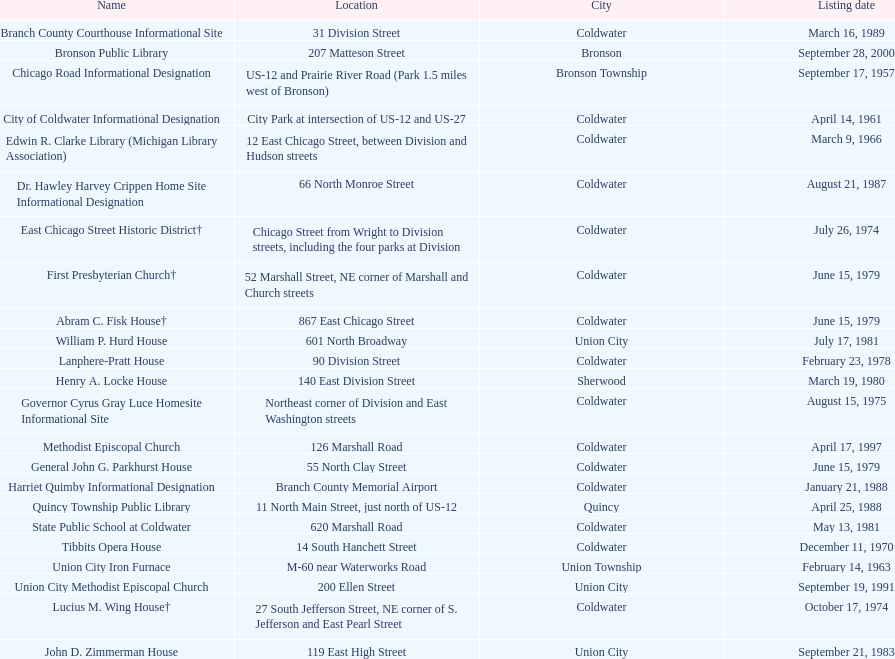Write the full table. {'header': ['Name', 'Location', 'City', 'Listing date'], 'rows': [['Branch County Courthouse Informational Site', '31 Division Street', 'Coldwater', 'March 16, 1989'], ['Bronson Public Library', '207 Matteson Street', 'Bronson', 'September 28, 2000'], ['Chicago Road Informational Designation', 'US-12 and Prairie River Road (Park 1.5 miles west of Bronson)', 'Bronson Township', 'September 17, 1957'], ['City of Coldwater Informational Designation', 'City Park at intersection of US-12 and US-27', 'Coldwater', 'April 14, 1961'], ['Edwin R. Clarke Library (Michigan Library Association)', '12 East Chicago Street, between Division and Hudson streets', 'Coldwater', 'March 9, 1966'], ['Dr. Hawley Harvey Crippen Home Site Informational Designation', '66 North Monroe Street', 'Coldwater', 'August 21, 1987'], ['East Chicago Street Historic District†', 'Chicago Street from Wright to Division streets, including the four parks at Division', 'Coldwater', 'July 26, 1974'], ['First Presbyterian Church†', '52 Marshall Street, NE corner of Marshall and Church streets', 'Coldwater', 'June 15, 1979'], ['Abram C. Fisk House†', '867 East Chicago Street', 'Coldwater', 'June 15, 1979'], ['William P. Hurd House', '601 North Broadway', 'Union City', 'July 17, 1981'], ['Lanphere-Pratt House', '90 Division Street', 'Coldwater', 'February 23, 1978'], ['Henry A. Locke House', '140 East Division Street', 'Sherwood', 'March 19, 1980'], ['Governor Cyrus Gray Luce Homesite Informational Site', 'Northeast corner of Division and East Washington streets', 'Coldwater', 'August 15, 1975'], ['Methodist Episcopal Church', '126 Marshall Road', 'Coldwater', 'April 17, 1997'], ['General John G. Parkhurst House', '55 North Clay Street', 'Coldwater', 'June 15, 1979'], ['Harriet Quimby Informational Designation', 'Branch County Memorial Airport', 'Coldwater', 'January 21, 1988'], ['Quincy Township Public Library', '11 North Main Street, just north of US-12', 'Quincy', 'April 25, 1988'], ['State Public School at Coldwater', '620 Marshall Road', 'Coldwater', 'May 13, 1981'], ['Tibbits Opera House', '14 South Hanchett Street', 'Coldwater', 'December 11, 1970'], ['Union City Iron Furnace', 'M-60 near Waterworks Road', 'Union Township', 'February 14, 1963'], ['Union City Methodist Episcopal Church', '200 Ellen Street', 'Union City', 'September 19, 1991'], ['Lucius M. Wing House†', '27 South Jefferson Street, NE corner of S. Jefferson and East Pearl Street', 'Coldwater', 'October 17, 1974'], ['John D. Zimmerman House', '119 East High Street', 'Union City', 'September 21, 1983']]} What is the count of historic sites listed in the year 1988? 2. 